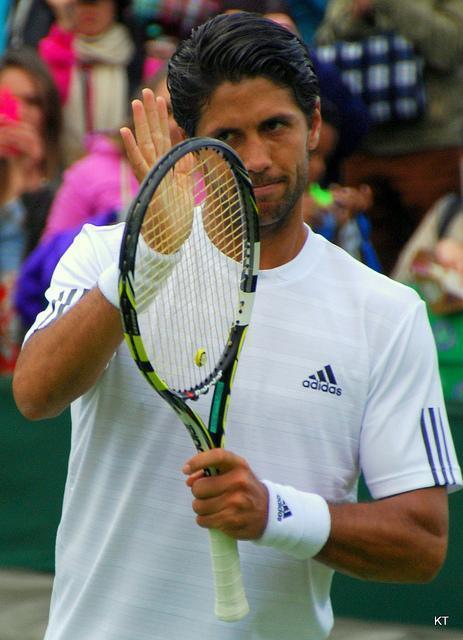How many people are in the photo?
Give a very brief answer. 5. How many laptops are visible?
Give a very brief answer. 0. 